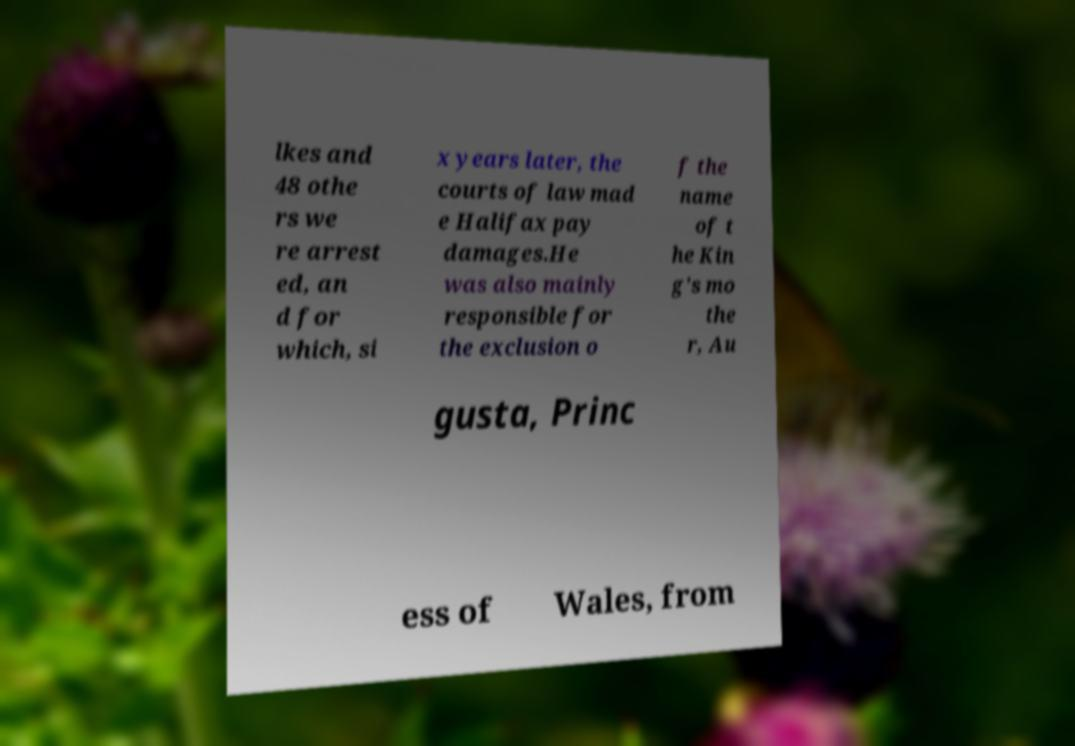Please read and relay the text visible in this image. What does it say? lkes and 48 othe rs we re arrest ed, an d for which, si x years later, the courts of law mad e Halifax pay damages.He was also mainly responsible for the exclusion o f the name of t he Kin g's mo the r, Au gusta, Princ ess of Wales, from 